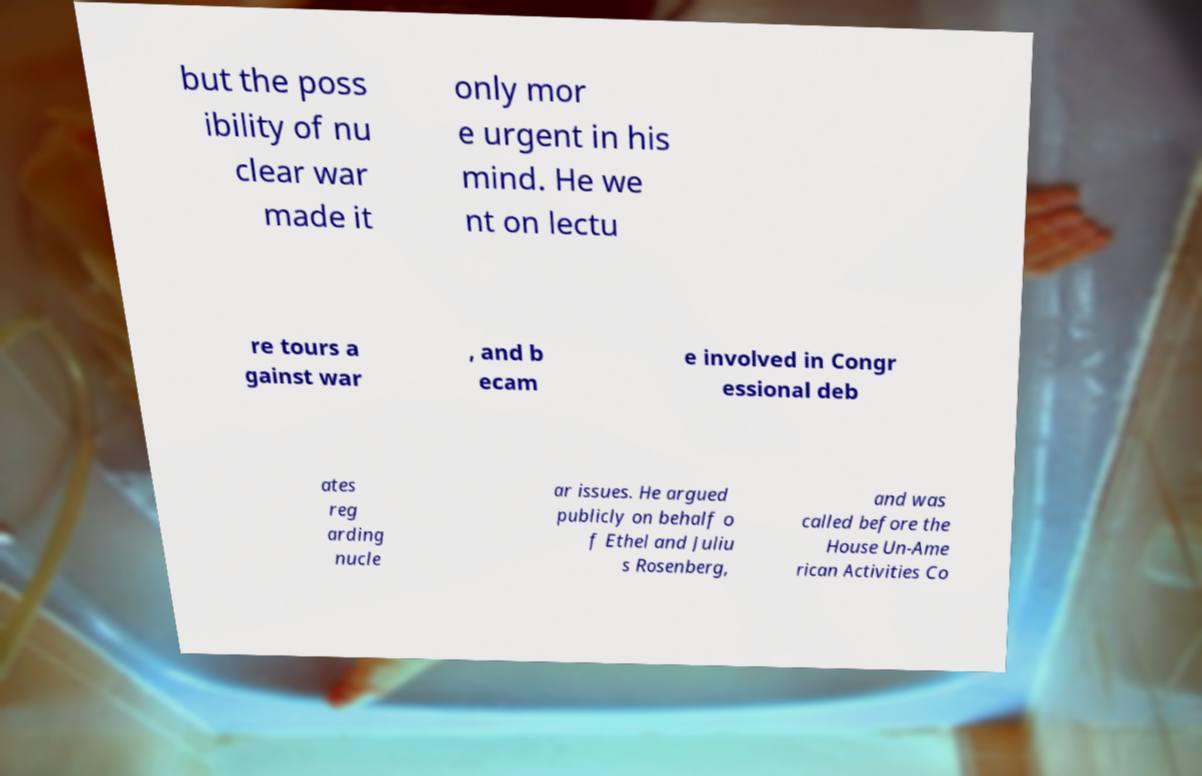Could you assist in decoding the text presented in this image and type it out clearly? but the poss ibility of nu clear war made it only mor e urgent in his mind. He we nt on lectu re tours a gainst war , and b ecam e involved in Congr essional deb ates reg arding nucle ar issues. He argued publicly on behalf o f Ethel and Juliu s Rosenberg, and was called before the House Un-Ame rican Activities Co 